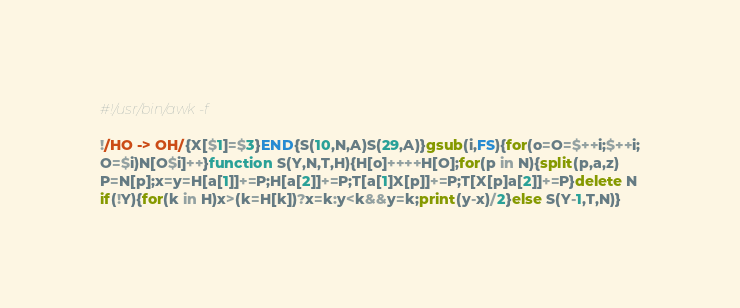Convert code to text. <code><loc_0><loc_0><loc_500><loc_500><_Awk_>#!/usr/bin/awk -f

!/HO -> OH/{X[$1]=$3}END{S(10,N,A)S(29,A)}gsub(i,FS){for(o=O=$++i;$++i;
O=$i)N[O$i]++}function S(Y,N,T,H){H[o]++++H[O];for(p in N){split(p,a,z)
P=N[p];x=y=H[a[1]]+=P;H[a[2]]+=P;T[a[1]X[p]]+=P;T[X[p]a[2]]+=P}delete N
if(!Y){for(k in H)x>(k=H[k])?x=k:y<k&&y=k;print(y-x)/2}else S(Y-1,T,N)}
</code> 